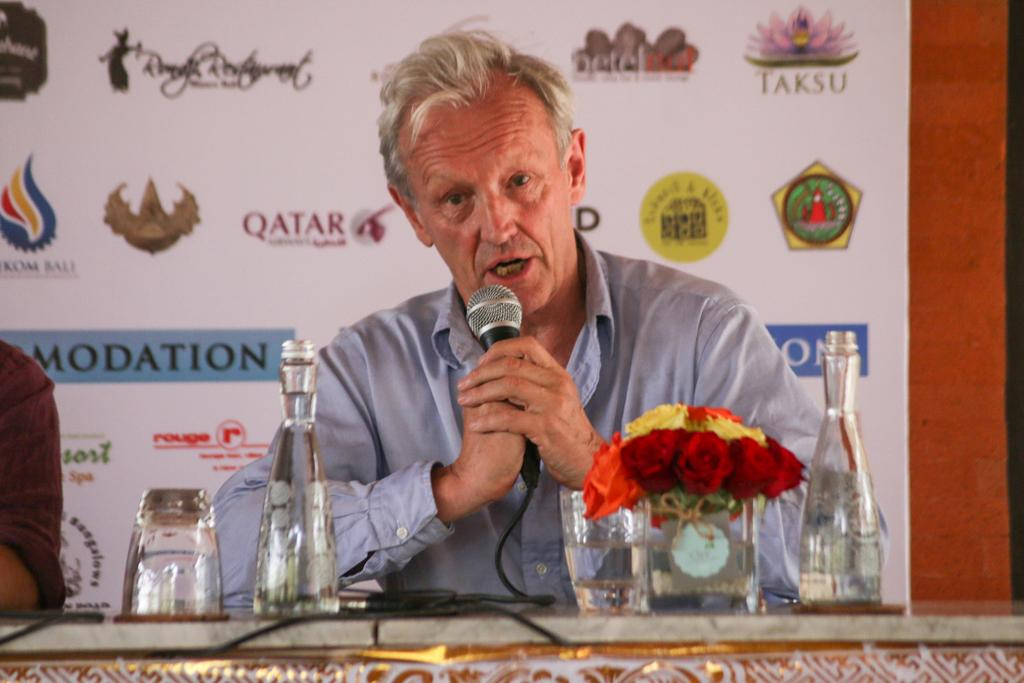What is the man in the image holding? The man is holding a mic in the image. What objects can be seen on the table in the image? There is a glass, a bottle, and a flower on the table in the image. What type of root can be seen growing from the man's head in the image? There is no root growing from the man's head in the image. What part of the man's body is responsible for his ability to speak into the mic? The man's brain, which is not visible in the image, is responsible for his ability to speak into the mic. 